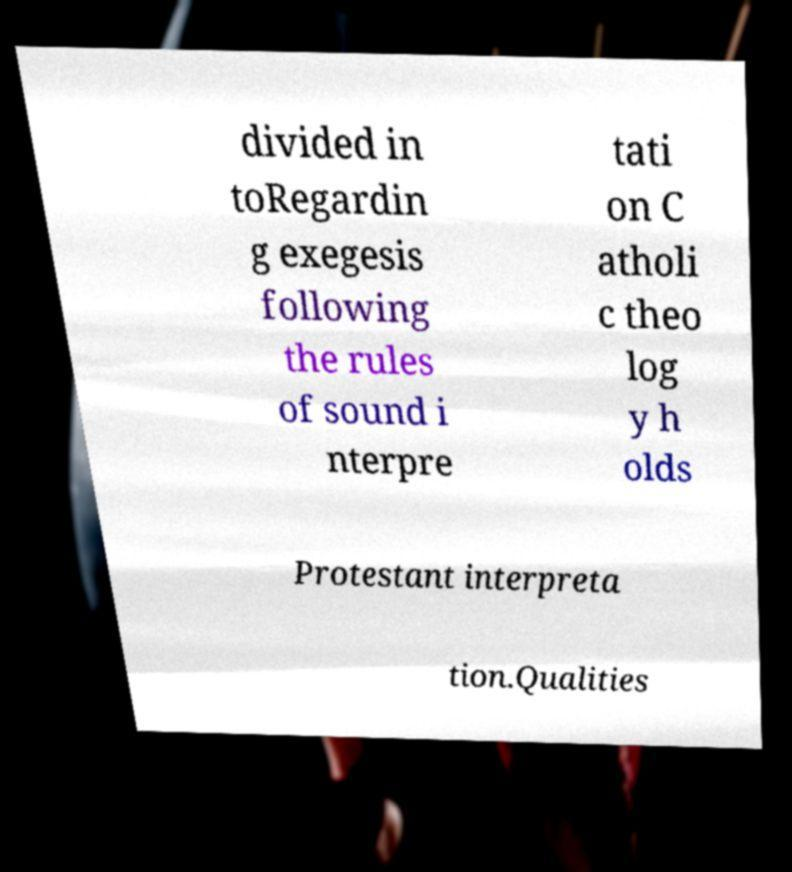Please identify and transcribe the text found in this image. divided in toRegardin g exegesis following the rules of sound i nterpre tati on C atholi c theo log y h olds Protestant interpreta tion.Qualities 